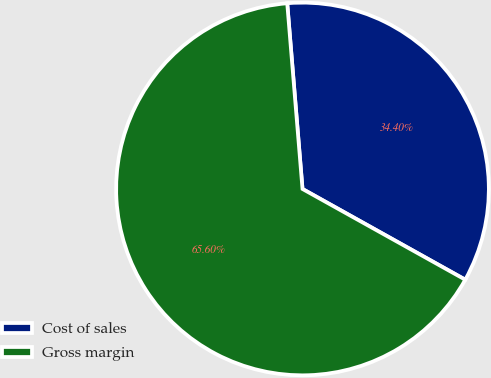<chart> <loc_0><loc_0><loc_500><loc_500><pie_chart><fcel>Cost of sales<fcel>Gross margin<nl><fcel>34.4%<fcel>65.6%<nl></chart> 